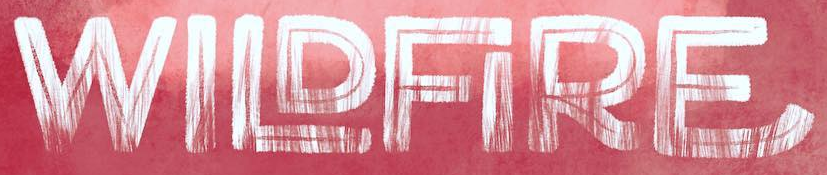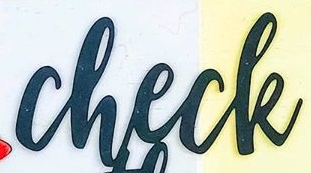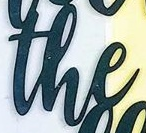Transcribe the words shown in these images in order, separated by a semicolon. WILDFIRE; check; the 